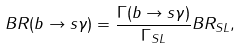Convert formula to latex. <formula><loc_0><loc_0><loc_500><loc_500>B R ( b \rightarrow s \gamma ) = \frac { \Gamma ( b \rightarrow s \gamma ) } { \Gamma _ { S L } } B R _ { S L } ,</formula> 